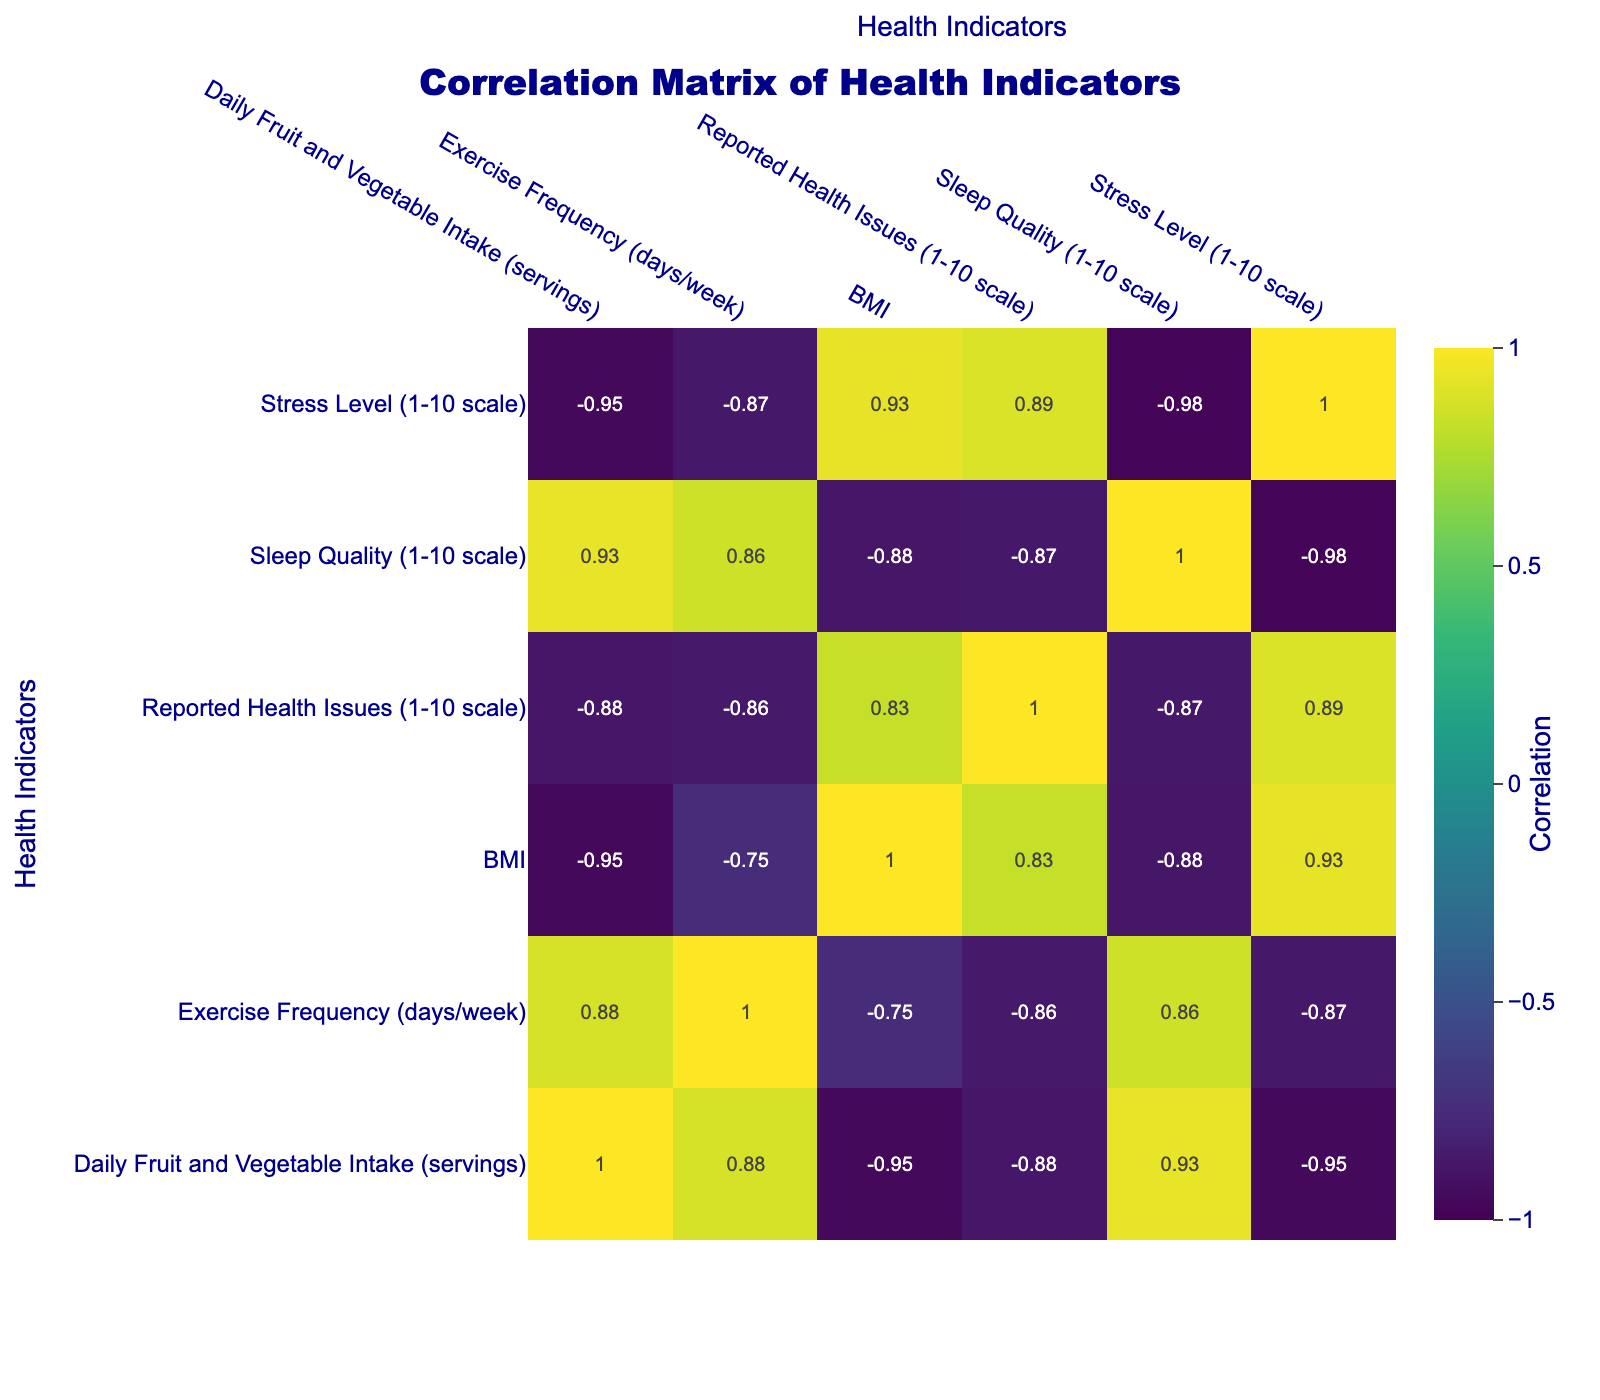What is the correlation between Daily Fruit and Vegetable Intake and Reported Health Issues? Looking at the correlation matrix, the correlation coefficient between Daily Fruit and Vegetable Intake and Reported Health Issues is -0.75. This indicates a strong negative correlation, suggesting that as daily fruit and vegetable intake increases, reported health issues tend to decrease.
Answer: -0.75 What diet choice shows the highest average sleep quality? To determine this, we need to find the sleep quality values for each diet choice and then calculate the average. The Vegan and Vegetarian diets both have a sleep quality of 9 and 9 respectively, which is the highest among all.
Answer: Vegan and Vegetarian (average sleep quality of 9) Is there a significant positive correlation between Exercise Frequency and Daily Fruit and Vegetable Intake? Examining the correlation matrix, the coefficient between Exercise Frequency and Daily Fruit and Vegetable Intake is 0.81, which is a strong positive correlation. This means that those who eat more fruits and vegetables tend to exercise more frequently.
Answer: Yes Which diet choice has the highest BMI and what is its value? Among the listed diet choices, the Fast Food Diet has the highest BMI at 29.0. This can be seen directly from the table provided.
Answer: 29.0 (Fast Food Diet) What is the average stress level for diets that have a reported health issue score lower than 4? The diets with a reported health issue score lower than 4 are Vegan (2), Mediterranean (1), Traditional Chinese (2), and Vegetarian (2). Their stress levels are 3, 4, 4, and 3 respectively. To find the average, sum the stress levels (3 + 4 + 4 + 3 = 14) and divide by the count of diets (4). Thus, the average stress level is 14 / 4 = 3.5.
Answer: 3.5 How many diet choices have a low-carb intake of three servings or less? The food choices with a low-carb intake are Low-Carb (3 servings), Fast Food Diet (1 serving), and Keto (2 servings). Counting these, there are three diet choices that meet this criterion.
Answer: 3 